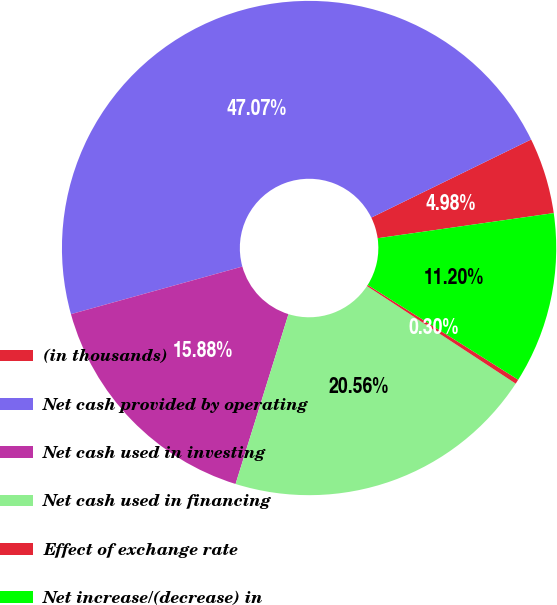<chart> <loc_0><loc_0><loc_500><loc_500><pie_chart><fcel>(in thousands)<fcel>Net cash provided by operating<fcel>Net cash used in investing<fcel>Net cash used in financing<fcel>Effect of exchange rate<fcel>Net increase/(decrease) in<nl><fcel>4.98%<fcel>47.07%<fcel>15.88%<fcel>20.56%<fcel>0.3%<fcel>11.2%<nl></chart> 